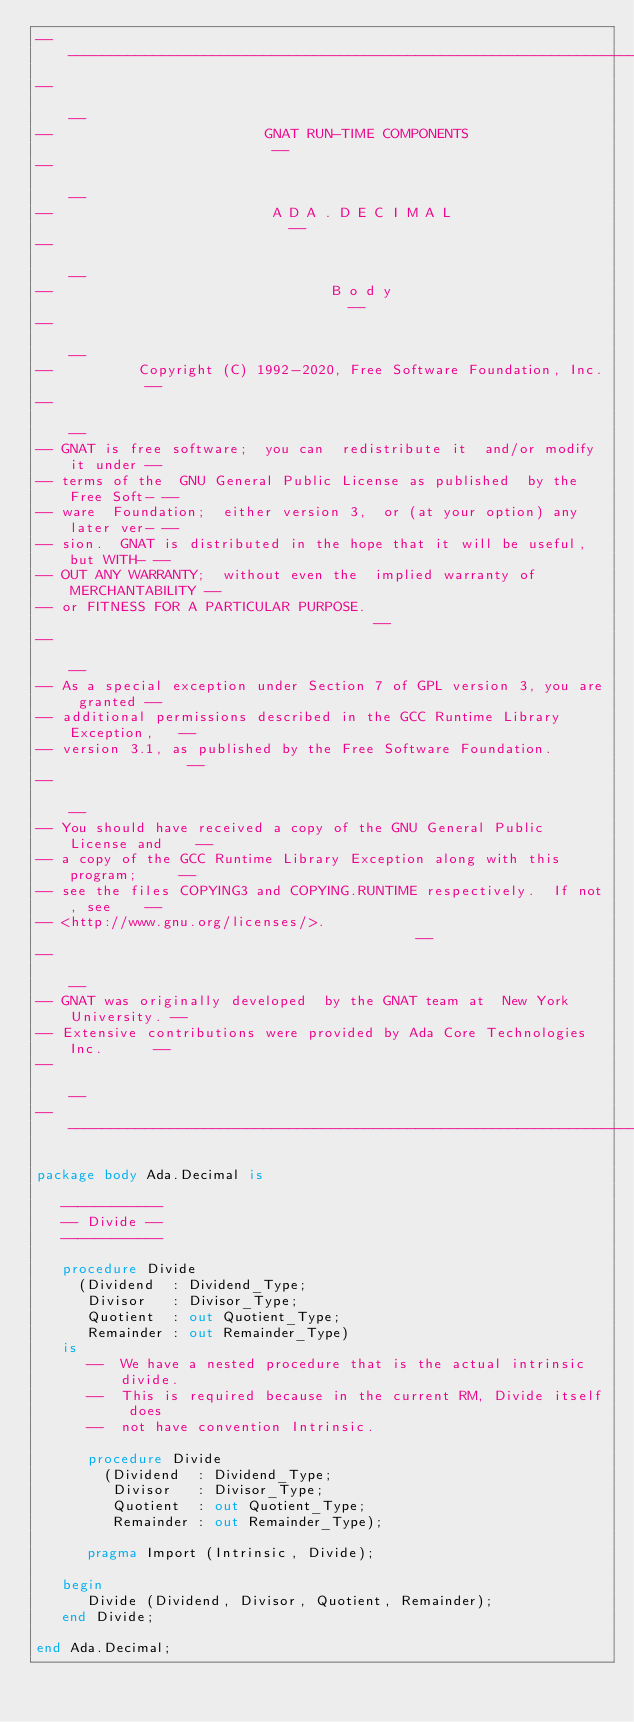Convert code to text. <code><loc_0><loc_0><loc_500><loc_500><_Ada_>------------------------------------------------------------------------------
--                                                                          --
--                         GNAT RUN-TIME COMPONENTS                         --
--                                                                          --
--                          A D A . D E C I M A L                           --
--                                                                          --
--                                 B o d y                                  --
--                                                                          --
--          Copyright (C) 1992-2020, Free Software Foundation, Inc.         --
--                                                                          --
-- GNAT is free software;  you can  redistribute it  and/or modify it under --
-- terms of the  GNU General Public License as published  by the Free Soft- --
-- ware  Foundation;  either version 3,  or (at your option) any later ver- --
-- sion.  GNAT is distributed in the hope that it will be useful, but WITH- --
-- OUT ANY WARRANTY;  without even the  implied warranty of MERCHANTABILITY --
-- or FITNESS FOR A PARTICULAR PURPOSE.                                     --
--                                                                          --
-- As a special exception under Section 7 of GPL version 3, you are granted --
-- additional permissions described in the GCC Runtime Library Exception,   --
-- version 3.1, as published by the Free Software Foundation.               --
--                                                                          --
-- You should have received a copy of the GNU General Public License and    --
-- a copy of the GCC Runtime Library Exception along with this program;     --
-- see the files COPYING3 and COPYING.RUNTIME respectively.  If not, see    --
-- <http://www.gnu.org/licenses/>.                                          --
--                                                                          --
-- GNAT was originally developed  by the GNAT team at  New York University. --
-- Extensive contributions were provided by Ada Core Technologies Inc.      --
--                                                                          --
------------------------------------------------------------------------------

package body Ada.Decimal is

   ------------
   -- Divide --
   ------------

   procedure Divide
     (Dividend  : Dividend_Type;
      Divisor   : Divisor_Type;
      Quotient  : out Quotient_Type;
      Remainder : out Remainder_Type)
   is
      --  We have a nested procedure that is the actual intrinsic divide.
      --  This is required because in the current RM, Divide itself does
      --  not have convention Intrinsic.

      procedure Divide
        (Dividend  : Dividend_Type;
         Divisor   : Divisor_Type;
         Quotient  : out Quotient_Type;
         Remainder : out Remainder_Type);

      pragma Import (Intrinsic, Divide);

   begin
      Divide (Dividend, Divisor, Quotient, Remainder);
   end Divide;

end Ada.Decimal;
</code> 